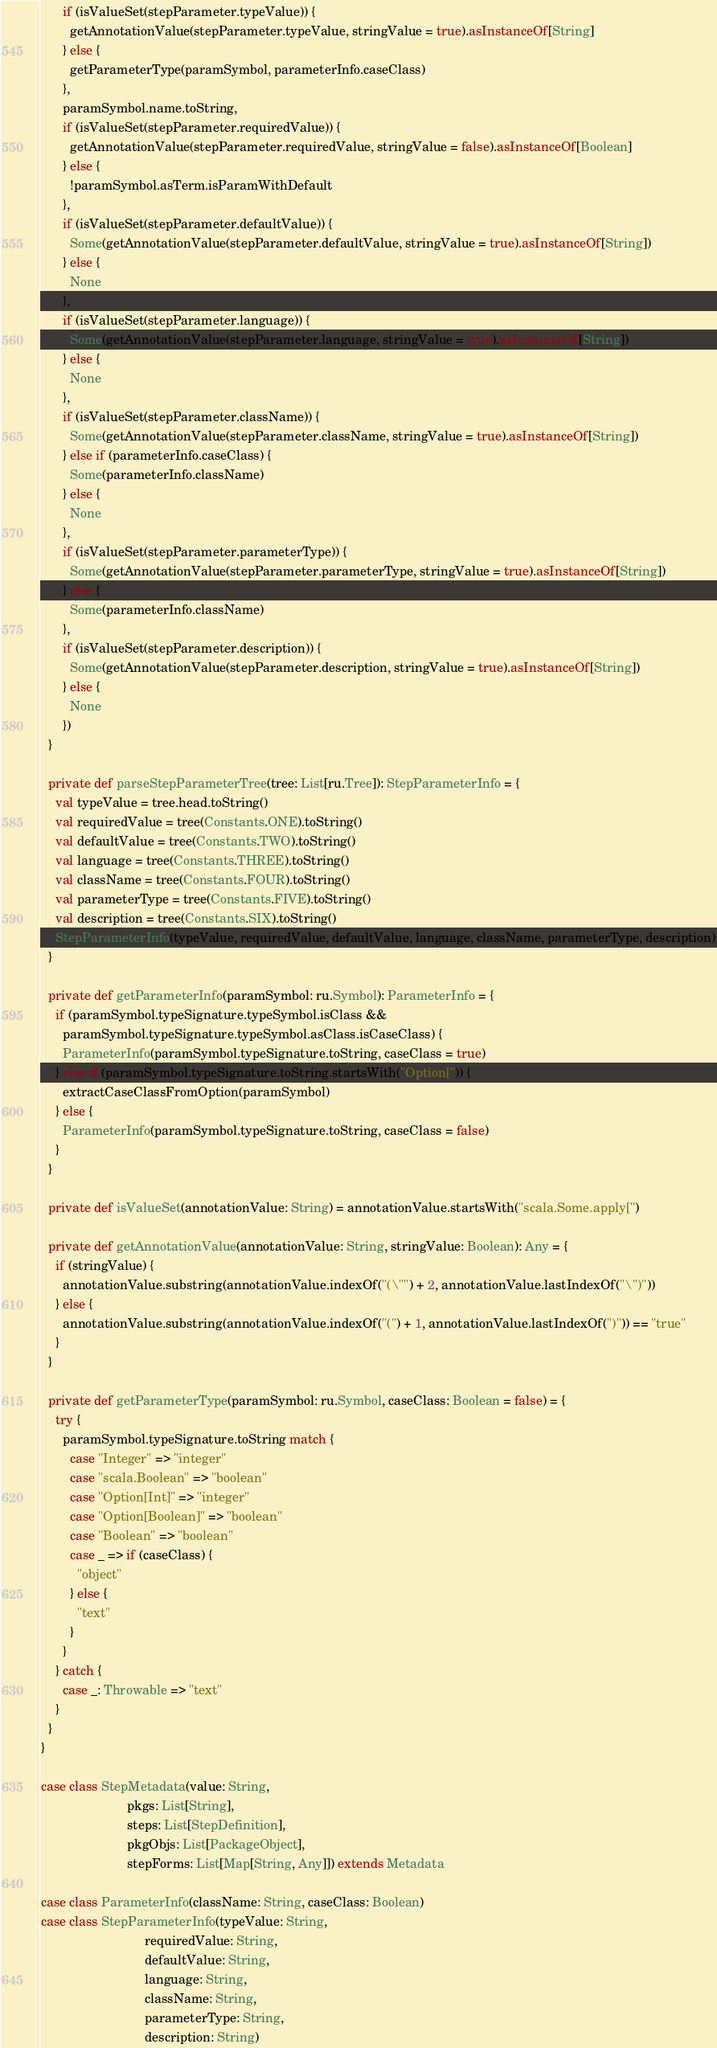<code> <loc_0><loc_0><loc_500><loc_500><_Scala_>      if (isValueSet(stepParameter.typeValue)) {
        getAnnotationValue(stepParameter.typeValue, stringValue = true).asInstanceOf[String]
      } else {
        getParameterType(paramSymbol, parameterInfo.caseClass)
      },
      paramSymbol.name.toString,
      if (isValueSet(stepParameter.requiredValue)) {
        getAnnotationValue(stepParameter.requiredValue, stringValue = false).asInstanceOf[Boolean]
      } else {
        !paramSymbol.asTerm.isParamWithDefault
      },
      if (isValueSet(stepParameter.defaultValue)) {
        Some(getAnnotationValue(stepParameter.defaultValue, stringValue = true).asInstanceOf[String])
      } else {
        None
      },
      if (isValueSet(stepParameter.language)) {
        Some(getAnnotationValue(stepParameter.language, stringValue = true).asInstanceOf[String])
      } else {
        None
      },
      if (isValueSet(stepParameter.className)) {
        Some(getAnnotationValue(stepParameter.className, stringValue = true).asInstanceOf[String])
      } else if (parameterInfo.caseClass) {
        Some(parameterInfo.className)
      } else {
        None
      },
      if (isValueSet(stepParameter.parameterType)) {
        Some(getAnnotationValue(stepParameter.parameterType, stringValue = true).asInstanceOf[String])
      } else {
        Some(parameterInfo.className)
      },
      if (isValueSet(stepParameter.description)) {
        Some(getAnnotationValue(stepParameter.description, stringValue = true).asInstanceOf[String])
      } else {
        None
      })
  }

  private def parseStepParameterTree(tree: List[ru.Tree]): StepParameterInfo = {
    val typeValue = tree.head.toString()
    val requiredValue = tree(Constants.ONE).toString()
    val defaultValue = tree(Constants.TWO).toString()
    val language = tree(Constants.THREE).toString()
    val className = tree(Constants.FOUR).toString()
    val parameterType = tree(Constants.FIVE).toString()
    val description = tree(Constants.SIX).toString()
    StepParameterInfo(typeValue, requiredValue, defaultValue, language, className, parameterType, description)
  }

  private def getParameterInfo(paramSymbol: ru.Symbol): ParameterInfo = {
    if (paramSymbol.typeSignature.typeSymbol.isClass &&
      paramSymbol.typeSignature.typeSymbol.asClass.isCaseClass) {
      ParameterInfo(paramSymbol.typeSignature.toString, caseClass = true)
    } else if (paramSymbol.typeSignature.toString.startsWith("Option[")) {
      extractCaseClassFromOption(paramSymbol)
    } else {
      ParameterInfo(paramSymbol.typeSignature.toString, caseClass = false)
    }
  }

  private def isValueSet(annotationValue: String) = annotationValue.startsWith("scala.Some.apply[")

  private def getAnnotationValue(annotationValue: String, stringValue: Boolean): Any = {
    if (stringValue) {
      annotationValue.substring(annotationValue.indexOf("(\"") + 2, annotationValue.lastIndexOf("\")"))
    } else {
      annotationValue.substring(annotationValue.indexOf("(") + 1, annotationValue.lastIndexOf(")")) == "true"
    }
  }

  private def getParameterType(paramSymbol: ru.Symbol, caseClass: Boolean = false) = {
    try {
      paramSymbol.typeSignature.toString match {
        case "Integer" => "integer"
        case "scala.Boolean" => "boolean"
        case "Option[Int]" => "integer"
        case "Option[Boolean]" => "boolean"
        case "Boolean" => "boolean"
        case _ => if (caseClass) {
          "object"
        } else {
          "text"
        }
      }
    } catch {
      case _: Throwable => "text"
    }
  }
}

case class StepMetadata(value: String,
                        pkgs: List[String],
                        steps: List[StepDefinition],
                        pkgObjs: List[PackageObject],
                        stepForms: List[Map[String, Any]]) extends Metadata

case class ParameterInfo(className: String, caseClass: Boolean)
case class StepParameterInfo(typeValue: String,
                             requiredValue: String,
                             defaultValue: String,
                             language: String,
                             className: String,
                             parameterType: String,
                             description: String)
</code> 